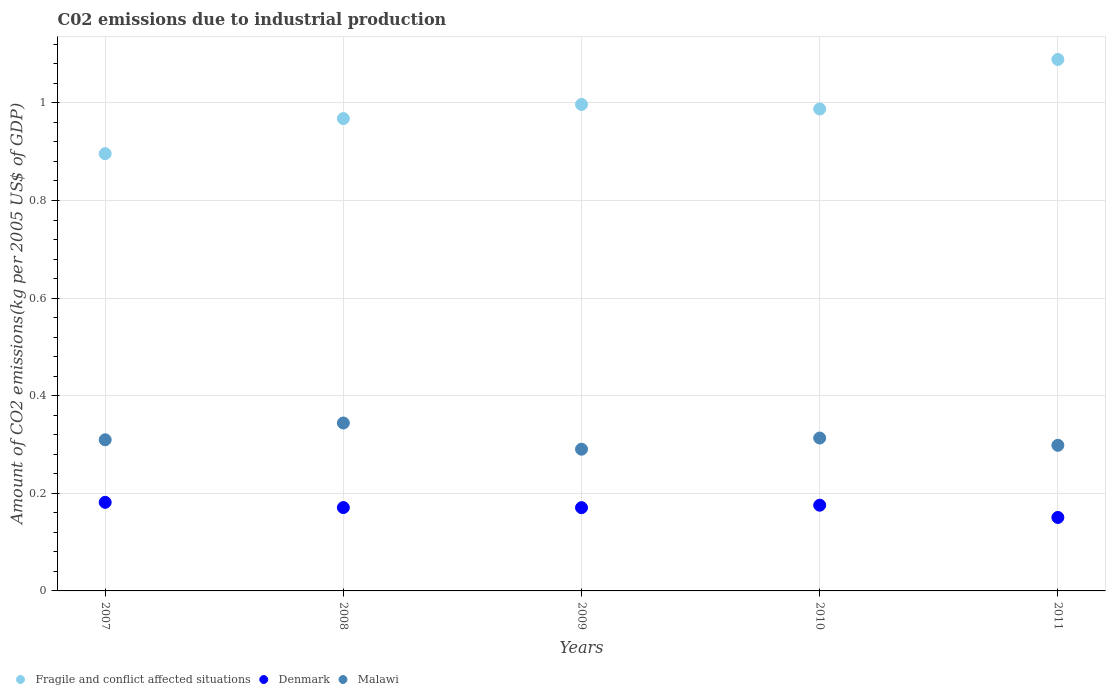What is the amount of CO2 emitted due to industrial production in Malawi in 2009?
Your answer should be compact. 0.29. Across all years, what is the maximum amount of CO2 emitted due to industrial production in Malawi?
Give a very brief answer. 0.34. Across all years, what is the minimum amount of CO2 emitted due to industrial production in Fragile and conflict affected situations?
Make the answer very short. 0.9. In which year was the amount of CO2 emitted due to industrial production in Fragile and conflict affected situations maximum?
Offer a very short reply. 2011. In which year was the amount of CO2 emitted due to industrial production in Denmark minimum?
Give a very brief answer. 2011. What is the total amount of CO2 emitted due to industrial production in Denmark in the graph?
Keep it short and to the point. 0.85. What is the difference between the amount of CO2 emitted due to industrial production in Fragile and conflict affected situations in 2007 and that in 2010?
Offer a terse response. -0.09. What is the difference between the amount of CO2 emitted due to industrial production in Fragile and conflict affected situations in 2011 and the amount of CO2 emitted due to industrial production in Malawi in 2010?
Your answer should be very brief. 0.78. What is the average amount of CO2 emitted due to industrial production in Denmark per year?
Your answer should be very brief. 0.17. In the year 2007, what is the difference between the amount of CO2 emitted due to industrial production in Malawi and amount of CO2 emitted due to industrial production in Fragile and conflict affected situations?
Make the answer very short. -0.59. In how many years, is the amount of CO2 emitted due to industrial production in Denmark greater than 0.36 kg?
Ensure brevity in your answer.  0. What is the ratio of the amount of CO2 emitted due to industrial production in Fragile and conflict affected situations in 2007 to that in 2011?
Keep it short and to the point. 0.82. Is the amount of CO2 emitted due to industrial production in Fragile and conflict affected situations in 2007 less than that in 2009?
Provide a short and direct response. Yes. What is the difference between the highest and the second highest amount of CO2 emitted due to industrial production in Malawi?
Offer a very short reply. 0.03. What is the difference between the highest and the lowest amount of CO2 emitted due to industrial production in Malawi?
Your answer should be compact. 0.05. Is it the case that in every year, the sum of the amount of CO2 emitted due to industrial production in Malawi and amount of CO2 emitted due to industrial production in Fragile and conflict affected situations  is greater than the amount of CO2 emitted due to industrial production in Denmark?
Provide a succinct answer. Yes. Does the amount of CO2 emitted due to industrial production in Malawi monotonically increase over the years?
Keep it short and to the point. No. Is the amount of CO2 emitted due to industrial production in Denmark strictly greater than the amount of CO2 emitted due to industrial production in Malawi over the years?
Provide a short and direct response. No. Is the amount of CO2 emitted due to industrial production in Denmark strictly less than the amount of CO2 emitted due to industrial production in Malawi over the years?
Your answer should be compact. Yes. What is the difference between two consecutive major ticks on the Y-axis?
Provide a succinct answer. 0.2. Are the values on the major ticks of Y-axis written in scientific E-notation?
Give a very brief answer. No. Where does the legend appear in the graph?
Ensure brevity in your answer.  Bottom left. How are the legend labels stacked?
Ensure brevity in your answer.  Horizontal. What is the title of the graph?
Give a very brief answer. C02 emissions due to industrial production. Does "Chile" appear as one of the legend labels in the graph?
Keep it short and to the point. No. What is the label or title of the X-axis?
Keep it short and to the point. Years. What is the label or title of the Y-axis?
Keep it short and to the point. Amount of CO2 emissions(kg per 2005 US$ of GDP). What is the Amount of CO2 emissions(kg per 2005 US$ of GDP) in Fragile and conflict affected situations in 2007?
Your answer should be compact. 0.9. What is the Amount of CO2 emissions(kg per 2005 US$ of GDP) of Denmark in 2007?
Provide a short and direct response. 0.18. What is the Amount of CO2 emissions(kg per 2005 US$ of GDP) in Malawi in 2007?
Offer a terse response. 0.31. What is the Amount of CO2 emissions(kg per 2005 US$ of GDP) in Fragile and conflict affected situations in 2008?
Offer a terse response. 0.97. What is the Amount of CO2 emissions(kg per 2005 US$ of GDP) in Denmark in 2008?
Provide a short and direct response. 0.17. What is the Amount of CO2 emissions(kg per 2005 US$ of GDP) in Malawi in 2008?
Ensure brevity in your answer.  0.34. What is the Amount of CO2 emissions(kg per 2005 US$ of GDP) of Fragile and conflict affected situations in 2009?
Offer a terse response. 1. What is the Amount of CO2 emissions(kg per 2005 US$ of GDP) of Denmark in 2009?
Your response must be concise. 0.17. What is the Amount of CO2 emissions(kg per 2005 US$ of GDP) of Malawi in 2009?
Your answer should be very brief. 0.29. What is the Amount of CO2 emissions(kg per 2005 US$ of GDP) in Fragile and conflict affected situations in 2010?
Give a very brief answer. 0.99. What is the Amount of CO2 emissions(kg per 2005 US$ of GDP) in Denmark in 2010?
Provide a succinct answer. 0.18. What is the Amount of CO2 emissions(kg per 2005 US$ of GDP) of Malawi in 2010?
Give a very brief answer. 0.31. What is the Amount of CO2 emissions(kg per 2005 US$ of GDP) in Fragile and conflict affected situations in 2011?
Ensure brevity in your answer.  1.09. What is the Amount of CO2 emissions(kg per 2005 US$ of GDP) in Denmark in 2011?
Your answer should be very brief. 0.15. What is the Amount of CO2 emissions(kg per 2005 US$ of GDP) in Malawi in 2011?
Provide a short and direct response. 0.3. Across all years, what is the maximum Amount of CO2 emissions(kg per 2005 US$ of GDP) in Fragile and conflict affected situations?
Offer a very short reply. 1.09. Across all years, what is the maximum Amount of CO2 emissions(kg per 2005 US$ of GDP) of Denmark?
Provide a short and direct response. 0.18. Across all years, what is the maximum Amount of CO2 emissions(kg per 2005 US$ of GDP) in Malawi?
Your answer should be compact. 0.34. Across all years, what is the minimum Amount of CO2 emissions(kg per 2005 US$ of GDP) in Fragile and conflict affected situations?
Provide a succinct answer. 0.9. Across all years, what is the minimum Amount of CO2 emissions(kg per 2005 US$ of GDP) of Denmark?
Your answer should be compact. 0.15. Across all years, what is the minimum Amount of CO2 emissions(kg per 2005 US$ of GDP) of Malawi?
Ensure brevity in your answer.  0.29. What is the total Amount of CO2 emissions(kg per 2005 US$ of GDP) in Fragile and conflict affected situations in the graph?
Offer a terse response. 4.94. What is the total Amount of CO2 emissions(kg per 2005 US$ of GDP) of Denmark in the graph?
Give a very brief answer. 0.85. What is the total Amount of CO2 emissions(kg per 2005 US$ of GDP) of Malawi in the graph?
Ensure brevity in your answer.  1.56. What is the difference between the Amount of CO2 emissions(kg per 2005 US$ of GDP) of Fragile and conflict affected situations in 2007 and that in 2008?
Your answer should be very brief. -0.07. What is the difference between the Amount of CO2 emissions(kg per 2005 US$ of GDP) in Denmark in 2007 and that in 2008?
Offer a terse response. 0.01. What is the difference between the Amount of CO2 emissions(kg per 2005 US$ of GDP) in Malawi in 2007 and that in 2008?
Offer a very short reply. -0.03. What is the difference between the Amount of CO2 emissions(kg per 2005 US$ of GDP) in Fragile and conflict affected situations in 2007 and that in 2009?
Ensure brevity in your answer.  -0.1. What is the difference between the Amount of CO2 emissions(kg per 2005 US$ of GDP) of Denmark in 2007 and that in 2009?
Your answer should be compact. 0.01. What is the difference between the Amount of CO2 emissions(kg per 2005 US$ of GDP) of Malawi in 2007 and that in 2009?
Give a very brief answer. 0.02. What is the difference between the Amount of CO2 emissions(kg per 2005 US$ of GDP) in Fragile and conflict affected situations in 2007 and that in 2010?
Make the answer very short. -0.09. What is the difference between the Amount of CO2 emissions(kg per 2005 US$ of GDP) in Denmark in 2007 and that in 2010?
Give a very brief answer. 0.01. What is the difference between the Amount of CO2 emissions(kg per 2005 US$ of GDP) of Malawi in 2007 and that in 2010?
Your answer should be very brief. -0. What is the difference between the Amount of CO2 emissions(kg per 2005 US$ of GDP) in Fragile and conflict affected situations in 2007 and that in 2011?
Your response must be concise. -0.19. What is the difference between the Amount of CO2 emissions(kg per 2005 US$ of GDP) of Denmark in 2007 and that in 2011?
Provide a succinct answer. 0.03. What is the difference between the Amount of CO2 emissions(kg per 2005 US$ of GDP) of Malawi in 2007 and that in 2011?
Provide a succinct answer. 0.01. What is the difference between the Amount of CO2 emissions(kg per 2005 US$ of GDP) of Fragile and conflict affected situations in 2008 and that in 2009?
Offer a very short reply. -0.03. What is the difference between the Amount of CO2 emissions(kg per 2005 US$ of GDP) of Malawi in 2008 and that in 2009?
Give a very brief answer. 0.05. What is the difference between the Amount of CO2 emissions(kg per 2005 US$ of GDP) in Fragile and conflict affected situations in 2008 and that in 2010?
Make the answer very short. -0.02. What is the difference between the Amount of CO2 emissions(kg per 2005 US$ of GDP) in Denmark in 2008 and that in 2010?
Your answer should be very brief. -0. What is the difference between the Amount of CO2 emissions(kg per 2005 US$ of GDP) of Malawi in 2008 and that in 2010?
Ensure brevity in your answer.  0.03. What is the difference between the Amount of CO2 emissions(kg per 2005 US$ of GDP) of Fragile and conflict affected situations in 2008 and that in 2011?
Provide a short and direct response. -0.12. What is the difference between the Amount of CO2 emissions(kg per 2005 US$ of GDP) in Denmark in 2008 and that in 2011?
Provide a short and direct response. 0.02. What is the difference between the Amount of CO2 emissions(kg per 2005 US$ of GDP) in Malawi in 2008 and that in 2011?
Your answer should be compact. 0.05. What is the difference between the Amount of CO2 emissions(kg per 2005 US$ of GDP) in Fragile and conflict affected situations in 2009 and that in 2010?
Offer a very short reply. 0.01. What is the difference between the Amount of CO2 emissions(kg per 2005 US$ of GDP) in Denmark in 2009 and that in 2010?
Provide a short and direct response. -0.01. What is the difference between the Amount of CO2 emissions(kg per 2005 US$ of GDP) in Malawi in 2009 and that in 2010?
Your answer should be compact. -0.02. What is the difference between the Amount of CO2 emissions(kg per 2005 US$ of GDP) in Fragile and conflict affected situations in 2009 and that in 2011?
Ensure brevity in your answer.  -0.09. What is the difference between the Amount of CO2 emissions(kg per 2005 US$ of GDP) in Denmark in 2009 and that in 2011?
Keep it short and to the point. 0.02. What is the difference between the Amount of CO2 emissions(kg per 2005 US$ of GDP) in Malawi in 2009 and that in 2011?
Your response must be concise. -0.01. What is the difference between the Amount of CO2 emissions(kg per 2005 US$ of GDP) in Fragile and conflict affected situations in 2010 and that in 2011?
Ensure brevity in your answer.  -0.1. What is the difference between the Amount of CO2 emissions(kg per 2005 US$ of GDP) of Denmark in 2010 and that in 2011?
Offer a very short reply. 0.03. What is the difference between the Amount of CO2 emissions(kg per 2005 US$ of GDP) of Malawi in 2010 and that in 2011?
Make the answer very short. 0.01. What is the difference between the Amount of CO2 emissions(kg per 2005 US$ of GDP) in Fragile and conflict affected situations in 2007 and the Amount of CO2 emissions(kg per 2005 US$ of GDP) in Denmark in 2008?
Your response must be concise. 0.73. What is the difference between the Amount of CO2 emissions(kg per 2005 US$ of GDP) of Fragile and conflict affected situations in 2007 and the Amount of CO2 emissions(kg per 2005 US$ of GDP) of Malawi in 2008?
Provide a short and direct response. 0.55. What is the difference between the Amount of CO2 emissions(kg per 2005 US$ of GDP) in Denmark in 2007 and the Amount of CO2 emissions(kg per 2005 US$ of GDP) in Malawi in 2008?
Offer a very short reply. -0.16. What is the difference between the Amount of CO2 emissions(kg per 2005 US$ of GDP) of Fragile and conflict affected situations in 2007 and the Amount of CO2 emissions(kg per 2005 US$ of GDP) of Denmark in 2009?
Keep it short and to the point. 0.73. What is the difference between the Amount of CO2 emissions(kg per 2005 US$ of GDP) of Fragile and conflict affected situations in 2007 and the Amount of CO2 emissions(kg per 2005 US$ of GDP) of Malawi in 2009?
Provide a succinct answer. 0.61. What is the difference between the Amount of CO2 emissions(kg per 2005 US$ of GDP) of Denmark in 2007 and the Amount of CO2 emissions(kg per 2005 US$ of GDP) of Malawi in 2009?
Give a very brief answer. -0.11. What is the difference between the Amount of CO2 emissions(kg per 2005 US$ of GDP) in Fragile and conflict affected situations in 2007 and the Amount of CO2 emissions(kg per 2005 US$ of GDP) in Denmark in 2010?
Your answer should be very brief. 0.72. What is the difference between the Amount of CO2 emissions(kg per 2005 US$ of GDP) of Fragile and conflict affected situations in 2007 and the Amount of CO2 emissions(kg per 2005 US$ of GDP) of Malawi in 2010?
Your response must be concise. 0.58. What is the difference between the Amount of CO2 emissions(kg per 2005 US$ of GDP) in Denmark in 2007 and the Amount of CO2 emissions(kg per 2005 US$ of GDP) in Malawi in 2010?
Offer a terse response. -0.13. What is the difference between the Amount of CO2 emissions(kg per 2005 US$ of GDP) of Fragile and conflict affected situations in 2007 and the Amount of CO2 emissions(kg per 2005 US$ of GDP) of Denmark in 2011?
Your answer should be compact. 0.75. What is the difference between the Amount of CO2 emissions(kg per 2005 US$ of GDP) of Fragile and conflict affected situations in 2007 and the Amount of CO2 emissions(kg per 2005 US$ of GDP) of Malawi in 2011?
Offer a very short reply. 0.6. What is the difference between the Amount of CO2 emissions(kg per 2005 US$ of GDP) in Denmark in 2007 and the Amount of CO2 emissions(kg per 2005 US$ of GDP) in Malawi in 2011?
Ensure brevity in your answer.  -0.12. What is the difference between the Amount of CO2 emissions(kg per 2005 US$ of GDP) of Fragile and conflict affected situations in 2008 and the Amount of CO2 emissions(kg per 2005 US$ of GDP) of Denmark in 2009?
Provide a succinct answer. 0.8. What is the difference between the Amount of CO2 emissions(kg per 2005 US$ of GDP) of Fragile and conflict affected situations in 2008 and the Amount of CO2 emissions(kg per 2005 US$ of GDP) of Malawi in 2009?
Offer a very short reply. 0.68. What is the difference between the Amount of CO2 emissions(kg per 2005 US$ of GDP) in Denmark in 2008 and the Amount of CO2 emissions(kg per 2005 US$ of GDP) in Malawi in 2009?
Offer a very short reply. -0.12. What is the difference between the Amount of CO2 emissions(kg per 2005 US$ of GDP) in Fragile and conflict affected situations in 2008 and the Amount of CO2 emissions(kg per 2005 US$ of GDP) in Denmark in 2010?
Keep it short and to the point. 0.79. What is the difference between the Amount of CO2 emissions(kg per 2005 US$ of GDP) in Fragile and conflict affected situations in 2008 and the Amount of CO2 emissions(kg per 2005 US$ of GDP) in Malawi in 2010?
Offer a terse response. 0.65. What is the difference between the Amount of CO2 emissions(kg per 2005 US$ of GDP) of Denmark in 2008 and the Amount of CO2 emissions(kg per 2005 US$ of GDP) of Malawi in 2010?
Provide a short and direct response. -0.14. What is the difference between the Amount of CO2 emissions(kg per 2005 US$ of GDP) in Fragile and conflict affected situations in 2008 and the Amount of CO2 emissions(kg per 2005 US$ of GDP) in Denmark in 2011?
Give a very brief answer. 0.82. What is the difference between the Amount of CO2 emissions(kg per 2005 US$ of GDP) of Fragile and conflict affected situations in 2008 and the Amount of CO2 emissions(kg per 2005 US$ of GDP) of Malawi in 2011?
Provide a succinct answer. 0.67. What is the difference between the Amount of CO2 emissions(kg per 2005 US$ of GDP) of Denmark in 2008 and the Amount of CO2 emissions(kg per 2005 US$ of GDP) of Malawi in 2011?
Offer a very short reply. -0.13. What is the difference between the Amount of CO2 emissions(kg per 2005 US$ of GDP) of Fragile and conflict affected situations in 2009 and the Amount of CO2 emissions(kg per 2005 US$ of GDP) of Denmark in 2010?
Offer a very short reply. 0.82. What is the difference between the Amount of CO2 emissions(kg per 2005 US$ of GDP) of Fragile and conflict affected situations in 2009 and the Amount of CO2 emissions(kg per 2005 US$ of GDP) of Malawi in 2010?
Your answer should be compact. 0.68. What is the difference between the Amount of CO2 emissions(kg per 2005 US$ of GDP) in Denmark in 2009 and the Amount of CO2 emissions(kg per 2005 US$ of GDP) in Malawi in 2010?
Give a very brief answer. -0.14. What is the difference between the Amount of CO2 emissions(kg per 2005 US$ of GDP) in Fragile and conflict affected situations in 2009 and the Amount of CO2 emissions(kg per 2005 US$ of GDP) in Denmark in 2011?
Your response must be concise. 0.85. What is the difference between the Amount of CO2 emissions(kg per 2005 US$ of GDP) of Fragile and conflict affected situations in 2009 and the Amount of CO2 emissions(kg per 2005 US$ of GDP) of Malawi in 2011?
Your answer should be compact. 0.7. What is the difference between the Amount of CO2 emissions(kg per 2005 US$ of GDP) in Denmark in 2009 and the Amount of CO2 emissions(kg per 2005 US$ of GDP) in Malawi in 2011?
Keep it short and to the point. -0.13. What is the difference between the Amount of CO2 emissions(kg per 2005 US$ of GDP) of Fragile and conflict affected situations in 2010 and the Amount of CO2 emissions(kg per 2005 US$ of GDP) of Denmark in 2011?
Provide a succinct answer. 0.84. What is the difference between the Amount of CO2 emissions(kg per 2005 US$ of GDP) in Fragile and conflict affected situations in 2010 and the Amount of CO2 emissions(kg per 2005 US$ of GDP) in Malawi in 2011?
Keep it short and to the point. 0.69. What is the difference between the Amount of CO2 emissions(kg per 2005 US$ of GDP) of Denmark in 2010 and the Amount of CO2 emissions(kg per 2005 US$ of GDP) of Malawi in 2011?
Your answer should be compact. -0.12. What is the average Amount of CO2 emissions(kg per 2005 US$ of GDP) in Fragile and conflict affected situations per year?
Offer a very short reply. 0.99. What is the average Amount of CO2 emissions(kg per 2005 US$ of GDP) in Denmark per year?
Offer a very short reply. 0.17. What is the average Amount of CO2 emissions(kg per 2005 US$ of GDP) in Malawi per year?
Provide a succinct answer. 0.31. In the year 2007, what is the difference between the Amount of CO2 emissions(kg per 2005 US$ of GDP) in Fragile and conflict affected situations and Amount of CO2 emissions(kg per 2005 US$ of GDP) in Denmark?
Your answer should be compact. 0.71. In the year 2007, what is the difference between the Amount of CO2 emissions(kg per 2005 US$ of GDP) of Fragile and conflict affected situations and Amount of CO2 emissions(kg per 2005 US$ of GDP) of Malawi?
Your response must be concise. 0.59. In the year 2007, what is the difference between the Amount of CO2 emissions(kg per 2005 US$ of GDP) of Denmark and Amount of CO2 emissions(kg per 2005 US$ of GDP) of Malawi?
Keep it short and to the point. -0.13. In the year 2008, what is the difference between the Amount of CO2 emissions(kg per 2005 US$ of GDP) of Fragile and conflict affected situations and Amount of CO2 emissions(kg per 2005 US$ of GDP) of Denmark?
Your answer should be very brief. 0.8. In the year 2008, what is the difference between the Amount of CO2 emissions(kg per 2005 US$ of GDP) of Fragile and conflict affected situations and Amount of CO2 emissions(kg per 2005 US$ of GDP) of Malawi?
Provide a short and direct response. 0.62. In the year 2008, what is the difference between the Amount of CO2 emissions(kg per 2005 US$ of GDP) in Denmark and Amount of CO2 emissions(kg per 2005 US$ of GDP) in Malawi?
Your answer should be very brief. -0.17. In the year 2009, what is the difference between the Amount of CO2 emissions(kg per 2005 US$ of GDP) of Fragile and conflict affected situations and Amount of CO2 emissions(kg per 2005 US$ of GDP) of Denmark?
Ensure brevity in your answer.  0.83. In the year 2009, what is the difference between the Amount of CO2 emissions(kg per 2005 US$ of GDP) of Fragile and conflict affected situations and Amount of CO2 emissions(kg per 2005 US$ of GDP) of Malawi?
Offer a terse response. 0.71. In the year 2009, what is the difference between the Amount of CO2 emissions(kg per 2005 US$ of GDP) of Denmark and Amount of CO2 emissions(kg per 2005 US$ of GDP) of Malawi?
Keep it short and to the point. -0.12. In the year 2010, what is the difference between the Amount of CO2 emissions(kg per 2005 US$ of GDP) in Fragile and conflict affected situations and Amount of CO2 emissions(kg per 2005 US$ of GDP) in Denmark?
Your answer should be compact. 0.81. In the year 2010, what is the difference between the Amount of CO2 emissions(kg per 2005 US$ of GDP) of Fragile and conflict affected situations and Amount of CO2 emissions(kg per 2005 US$ of GDP) of Malawi?
Your response must be concise. 0.67. In the year 2010, what is the difference between the Amount of CO2 emissions(kg per 2005 US$ of GDP) of Denmark and Amount of CO2 emissions(kg per 2005 US$ of GDP) of Malawi?
Offer a terse response. -0.14. In the year 2011, what is the difference between the Amount of CO2 emissions(kg per 2005 US$ of GDP) of Fragile and conflict affected situations and Amount of CO2 emissions(kg per 2005 US$ of GDP) of Denmark?
Make the answer very short. 0.94. In the year 2011, what is the difference between the Amount of CO2 emissions(kg per 2005 US$ of GDP) in Fragile and conflict affected situations and Amount of CO2 emissions(kg per 2005 US$ of GDP) in Malawi?
Your response must be concise. 0.79. In the year 2011, what is the difference between the Amount of CO2 emissions(kg per 2005 US$ of GDP) of Denmark and Amount of CO2 emissions(kg per 2005 US$ of GDP) of Malawi?
Offer a terse response. -0.15. What is the ratio of the Amount of CO2 emissions(kg per 2005 US$ of GDP) in Fragile and conflict affected situations in 2007 to that in 2008?
Make the answer very short. 0.93. What is the ratio of the Amount of CO2 emissions(kg per 2005 US$ of GDP) in Denmark in 2007 to that in 2008?
Provide a short and direct response. 1.06. What is the ratio of the Amount of CO2 emissions(kg per 2005 US$ of GDP) of Malawi in 2007 to that in 2008?
Your answer should be very brief. 0.9. What is the ratio of the Amount of CO2 emissions(kg per 2005 US$ of GDP) of Fragile and conflict affected situations in 2007 to that in 2009?
Your answer should be very brief. 0.9. What is the ratio of the Amount of CO2 emissions(kg per 2005 US$ of GDP) of Denmark in 2007 to that in 2009?
Your answer should be compact. 1.06. What is the ratio of the Amount of CO2 emissions(kg per 2005 US$ of GDP) in Malawi in 2007 to that in 2009?
Ensure brevity in your answer.  1.07. What is the ratio of the Amount of CO2 emissions(kg per 2005 US$ of GDP) in Fragile and conflict affected situations in 2007 to that in 2010?
Make the answer very short. 0.91. What is the ratio of the Amount of CO2 emissions(kg per 2005 US$ of GDP) in Denmark in 2007 to that in 2010?
Ensure brevity in your answer.  1.03. What is the ratio of the Amount of CO2 emissions(kg per 2005 US$ of GDP) in Malawi in 2007 to that in 2010?
Give a very brief answer. 0.99. What is the ratio of the Amount of CO2 emissions(kg per 2005 US$ of GDP) in Fragile and conflict affected situations in 2007 to that in 2011?
Your answer should be very brief. 0.82. What is the ratio of the Amount of CO2 emissions(kg per 2005 US$ of GDP) of Denmark in 2007 to that in 2011?
Your answer should be very brief. 1.21. What is the ratio of the Amount of CO2 emissions(kg per 2005 US$ of GDP) of Malawi in 2007 to that in 2011?
Your answer should be compact. 1.04. What is the ratio of the Amount of CO2 emissions(kg per 2005 US$ of GDP) of Fragile and conflict affected situations in 2008 to that in 2009?
Give a very brief answer. 0.97. What is the ratio of the Amount of CO2 emissions(kg per 2005 US$ of GDP) of Denmark in 2008 to that in 2009?
Give a very brief answer. 1. What is the ratio of the Amount of CO2 emissions(kg per 2005 US$ of GDP) in Malawi in 2008 to that in 2009?
Give a very brief answer. 1.19. What is the ratio of the Amount of CO2 emissions(kg per 2005 US$ of GDP) in Fragile and conflict affected situations in 2008 to that in 2010?
Your answer should be compact. 0.98. What is the ratio of the Amount of CO2 emissions(kg per 2005 US$ of GDP) of Denmark in 2008 to that in 2010?
Give a very brief answer. 0.97. What is the ratio of the Amount of CO2 emissions(kg per 2005 US$ of GDP) of Malawi in 2008 to that in 2010?
Your response must be concise. 1.1. What is the ratio of the Amount of CO2 emissions(kg per 2005 US$ of GDP) of Fragile and conflict affected situations in 2008 to that in 2011?
Provide a short and direct response. 0.89. What is the ratio of the Amount of CO2 emissions(kg per 2005 US$ of GDP) in Denmark in 2008 to that in 2011?
Make the answer very short. 1.13. What is the ratio of the Amount of CO2 emissions(kg per 2005 US$ of GDP) in Malawi in 2008 to that in 2011?
Your answer should be compact. 1.15. What is the ratio of the Amount of CO2 emissions(kg per 2005 US$ of GDP) of Fragile and conflict affected situations in 2009 to that in 2010?
Make the answer very short. 1.01. What is the ratio of the Amount of CO2 emissions(kg per 2005 US$ of GDP) of Denmark in 2009 to that in 2010?
Provide a short and direct response. 0.97. What is the ratio of the Amount of CO2 emissions(kg per 2005 US$ of GDP) of Malawi in 2009 to that in 2010?
Provide a short and direct response. 0.93. What is the ratio of the Amount of CO2 emissions(kg per 2005 US$ of GDP) in Fragile and conflict affected situations in 2009 to that in 2011?
Offer a very short reply. 0.92. What is the ratio of the Amount of CO2 emissions(kg per 2005 US$ of GDP) in Denmark in 2009 to that in 2011?
Provide a succinct answer. 1.13. What is the ratio of the Amount of CO2 emissions(kg per 2005 US$ of GDP) in Malawi in 2009 to that in 2011?
Your response must be concise. 0.97. What is the ratio of the Amount of CO2 emissions(kg per 2005 US$ of GDP) of Fragile and conflict affected situations in 2010 to that in 2011?
Offer a terse response. 0.91. What is the ratio of the Amount of CO2 emissions(kg per 2005 US$ of GDP) in Malawi in 2010 to that in 2011?
Give a very brief answer. 1.05. What is the difference between the highest and the second highest Amount of CO2 emissions(kg per 2005 US$ of GDP) in Fragile and conflict affected situations?
Your response must be concise. 0.09. What is the difference between the highest and the second highest Amount of CO2 emissions(kg per 2005 US$ of GDP) in Denmark?
Offer a very short reply. 0.01. What is the difference between the highest and the second highest Amount of CO2 emissions(kg per 2005 US$ of GDP) of Malawi?
Provide a short and direct response. 0.03. What is the difference between the highest and the lowest Amount of CO2 emissions(kg per 2005 US$ of GDP) of Fragile and conflict affected situations?
Offer a very short reply. 0.19. What is the difference between the highest and the lowest Amount of CO2 emissions(kg per 2005 US$ of GDP) of Denmark?
Your answer should be very brief. 0.03. What is the difference between the highest and the lowest Amount of CO2 emissions(kg per 2005 US$ of GDP) of Malawi?
Your response must be concise. 0.05. 